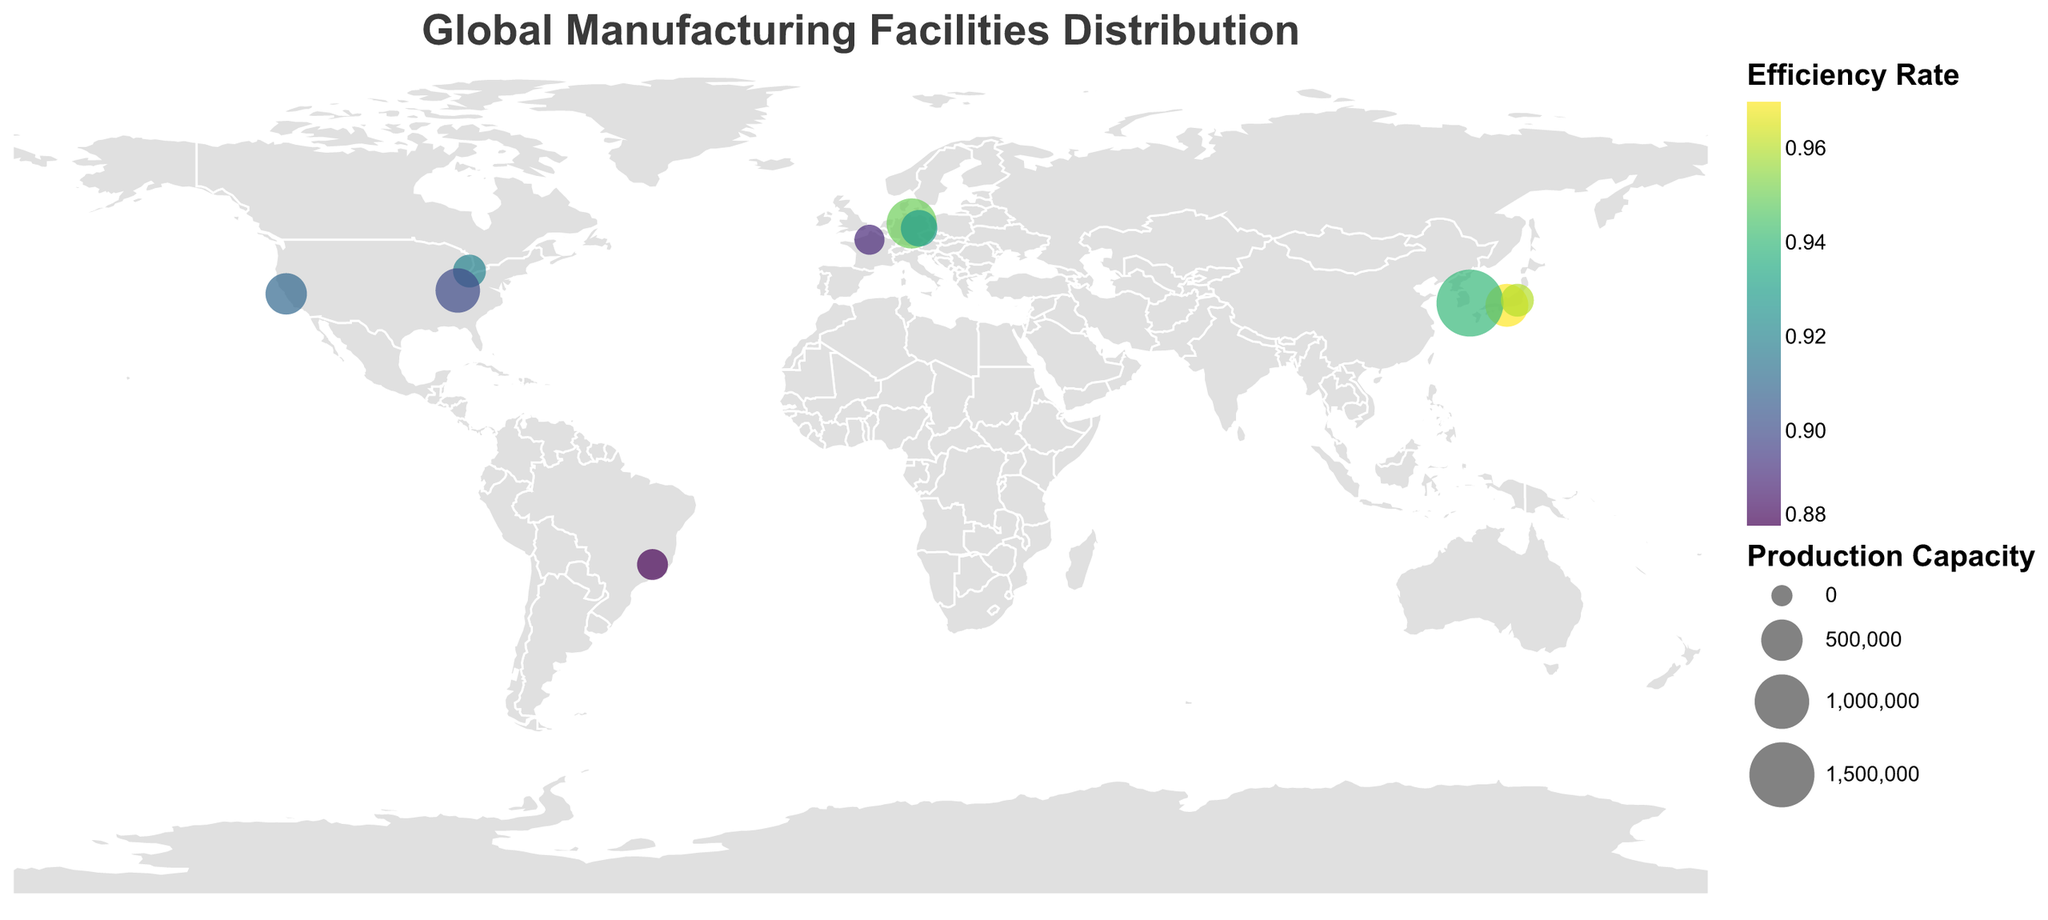What is the title of the plot? The title of the plot is clearly displayed at the top of the figure.
Answer: Global Manufacturing Facilities Distribution How many manufacturing facilities are shown on the map? By counting the number of data points, each representing a manufacturing facility, we can determine how many facilities are shown. There are 10 data points for each facility.
Answer: 10 Which facility has the highest production capacity, and what is its value? By looking at the size of the circles representing production capacity, we identify the largest circle. The largest circle corresponds to the Hyundai Ulsan Plant in Asia with a production capacity of 1,600,000 units.
Answer: Hyundai Ulsan Plant, 1,600,000 units Which facility in Europe has the lowest efficiency rate, and what is the rate? By examining the color of the circles representing efficiency rate in Europe, the darkest circle, indicating the lowest efficiency, corresponds to the Renault Flins Factory. Its efficiency rate is 0.89.
Answer: Renault Flins Factory, 0.89 Between the Ford Kentucky Truck Plant and Tesla Fremont Factory, which has a higher production capacity? Compare the sizes of the circles representing the Ford Kentucky Truck Plant and the Tesla Fremont Factory. The Ford Kentucky Truck Plant has a larger circle and thus a higher production capacity of 605,000 units compared to Tesla's 500,000 units.
Answer: Ford Kentucky Truck Plant What is the average efficiency rate of the manufacturing facilities in North America? Locate the facilities in North America (Detroit Assembly Plant, Tesla Fremont Factory, Ford Kentucky Truck Plant). Sum their efficiency rates (0.92, 0.91, 0.90) and divide by the number of facilities, which is 3. (0.92 + 0.91 + 0.90) / 3 = 0.91
Answer: 0.91 Which region has the most facilities, and how many are there? Count the number of facilities in each region. Asia has the most facilities with 3 (Toyota Takaoka Plant, Hyundai Ulsan Plant, and Honda Saitama Factory).
Answer: Asia, 3 What is the difference in production capacity between the highest and lowest capacity facilities? Identify the facilities with the highest (Hyundai Ulsan Plant, 1,600,000 units) and the lowest (Renault Flins Factory, 180,000 units) production capacities. Subtract the lowest from the highest: 1,600,000 - 180,000 = 1,420,000 units.
Answer: 1,420,000 units Which facility in Asia has the highest efficiency rate, and what is it? By examining the color of the circles representing efficiency rate in Asia, the lightest circle indicating the highest efficiency corresponds to the Toyota Takaoka Plant with an efficiency rate of 0.97.
Answer: Toyota Takaoka Plant, 0.97 What is the total production capacity of all manufacturing facilities in Europe? Sum the production capacities of all facilities in Europe (Wolfsburg Volkswagen Factory, BMW Leipzig Plant, Renault Flins Factory): 815,000 + 350,000 + 180,000 = 1,345,000 units.
Answer: 1,345,000 units 